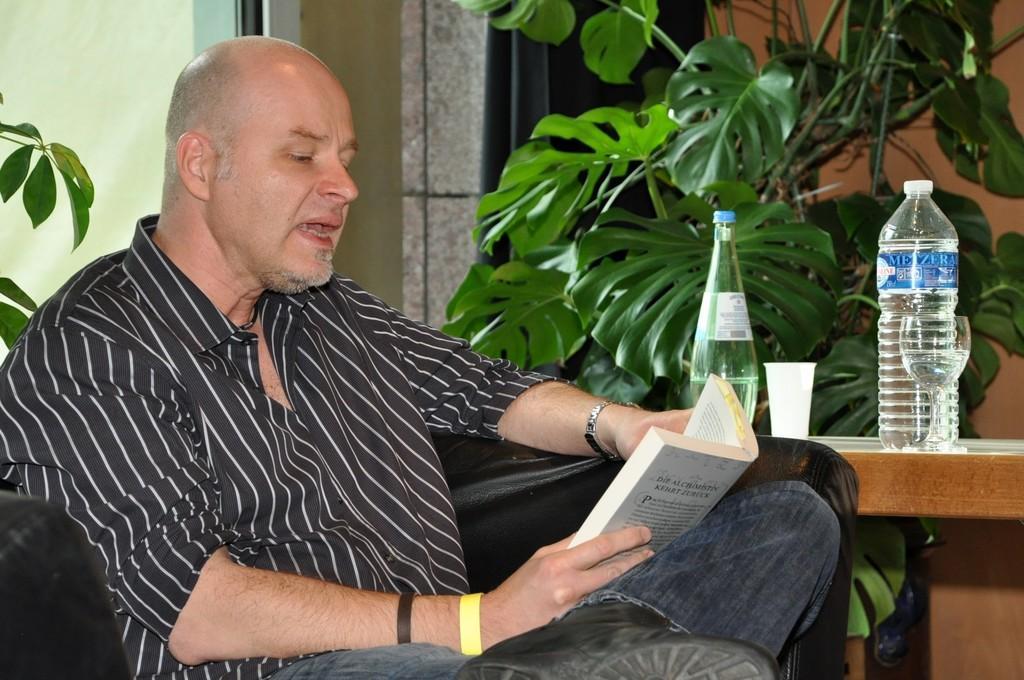Could you give a brief overview of what you see in this image? In this picture there is a man sitting on couch and reading a book. He is wearing a black shirt and blue jeans. Beside him there is a table and on the table there are glasses and water bottles. Behind him there is a plant. In the background there is wall and a houseplant.  